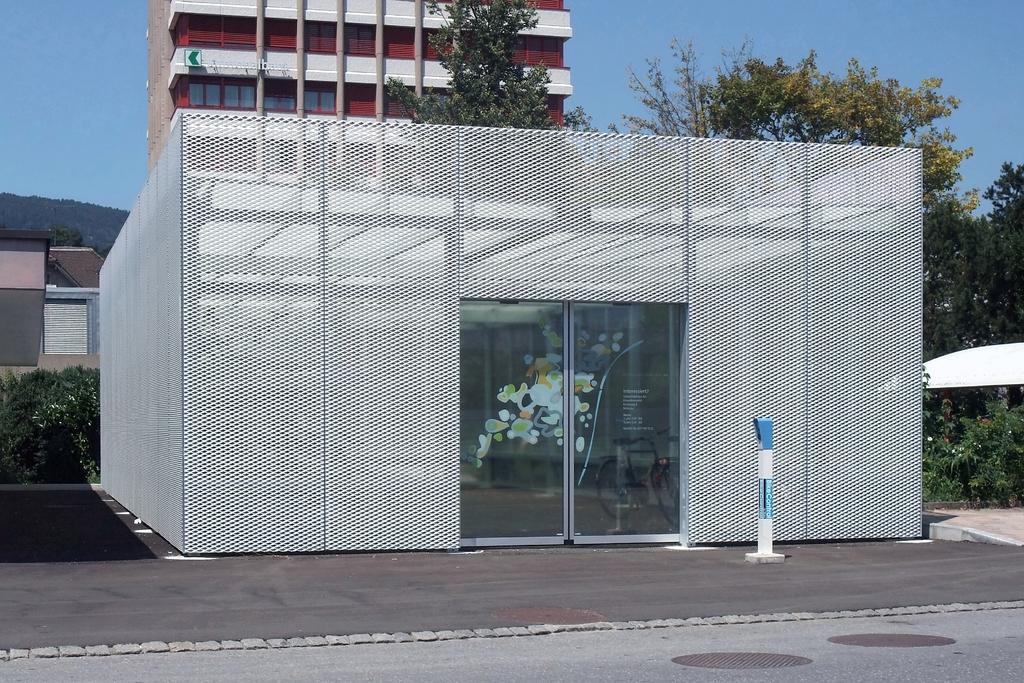In one or two sentences, can you explain what this image depicts? In this image we can see sky, buildings, trees, bicycle inside the grill shed and road. 